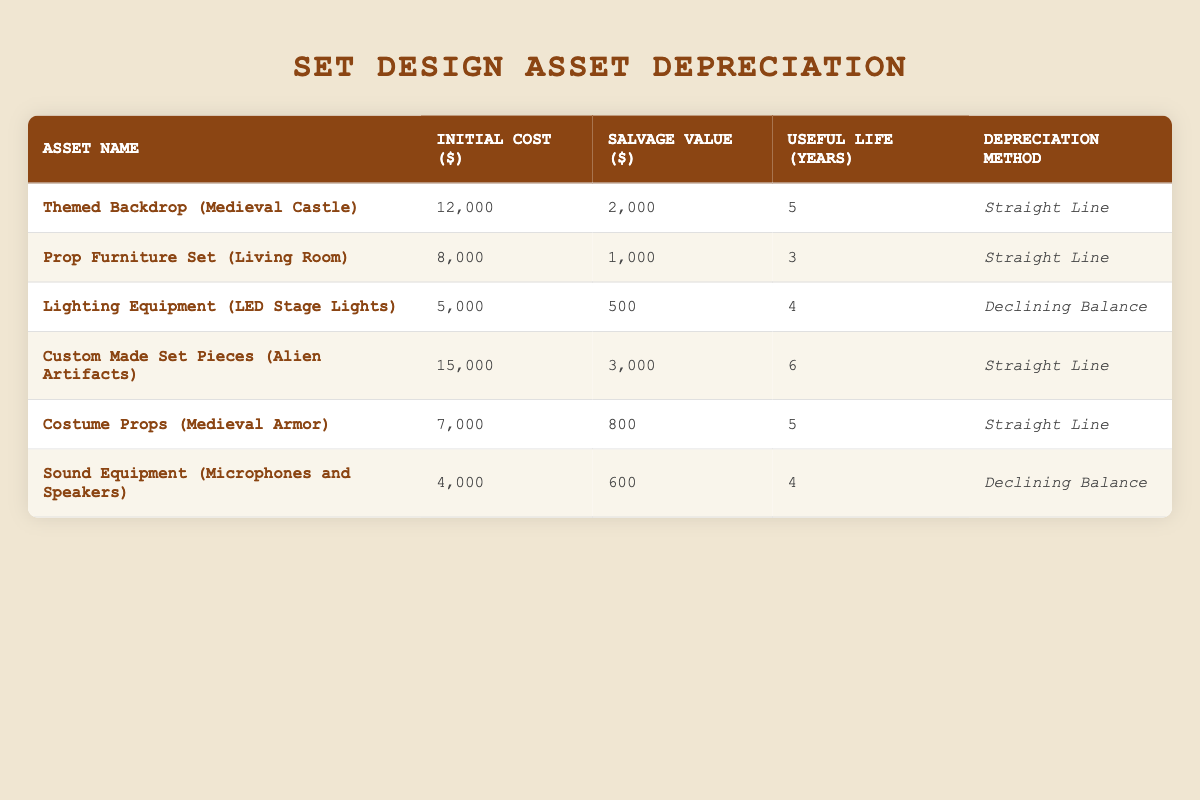What is the initial cost of the Lighting Equipment (LED Stage Lights)? The initial cost is listed directly in the table under the corresponding asset. For the Lighting Equipment (LED Stage Lights), the value is specified alongside the asset name.
Answer: 5000 How many years of useful life does the Custom Made Set Pieces (Alien Artifacts) have? The useful life is listed in the table for each asset, and for the Custom Made Set Pieces (Alien Artifacts), the specified duration is recorded next to its name.
Answer: 6 Which asset has the highest salvage value? To determine this, the salvage value must be compared across all assets listed in the table. By reviewing, Custom Made Set Pieces (Alien Artifacts) has a salvage value of 3000, which is the highest.
Answer: 3000 What is the total initial cost of all assets? The initial costs need to be summed: 12000 + 8000 + 5000 + 15000 + 7000 + 4000 = 40000. Therefore, the total initial cost for all assets is obtained by adding these values together.
Answer: 40000 Is the depreciation method for the Prop Furniture Set (Living Room) Straight Line? Checking the table, the depreciation method specified for the Prop Furniture Set (Living Room) confirms it is indeed designated as Straight Line.
Answer: Yes Which asset has the lowest initial cost? The lowest initial cost will be determined by examining the initial costs of all assets in the table. The Sound Equipment (Microphones and Speakers) is noted to have the lowest cost at 4000.
Answer: 4000 What is the average salvage value of all assets? To find the average salvage value, sum the salvage values: 2000 + 1000 + 500 + 3000 + 800 + 600 = 5910. Then divide by the number of assets (6): 5910 / 6 = 985.
Answer: 985 How many assets have a useful life of 5 years or longer? Review the useful life for each asset: Themed Backdrop (Medieval Castle), Custom Made Set Pieces (Alien Artifacts), and Costume Props (Medieval Armor) all qualify as having 5 or more years of useful life. This totals three assets meeting the criteria.
Answer: 3 Is there any asset with a useful life of less than 4 years? By reviewing the useful life data, in the table, the Prop Furniture Set (Living Room) has a useful life of 3 years, confirming that at least one asset does meet this condition.
Answer: Yes 